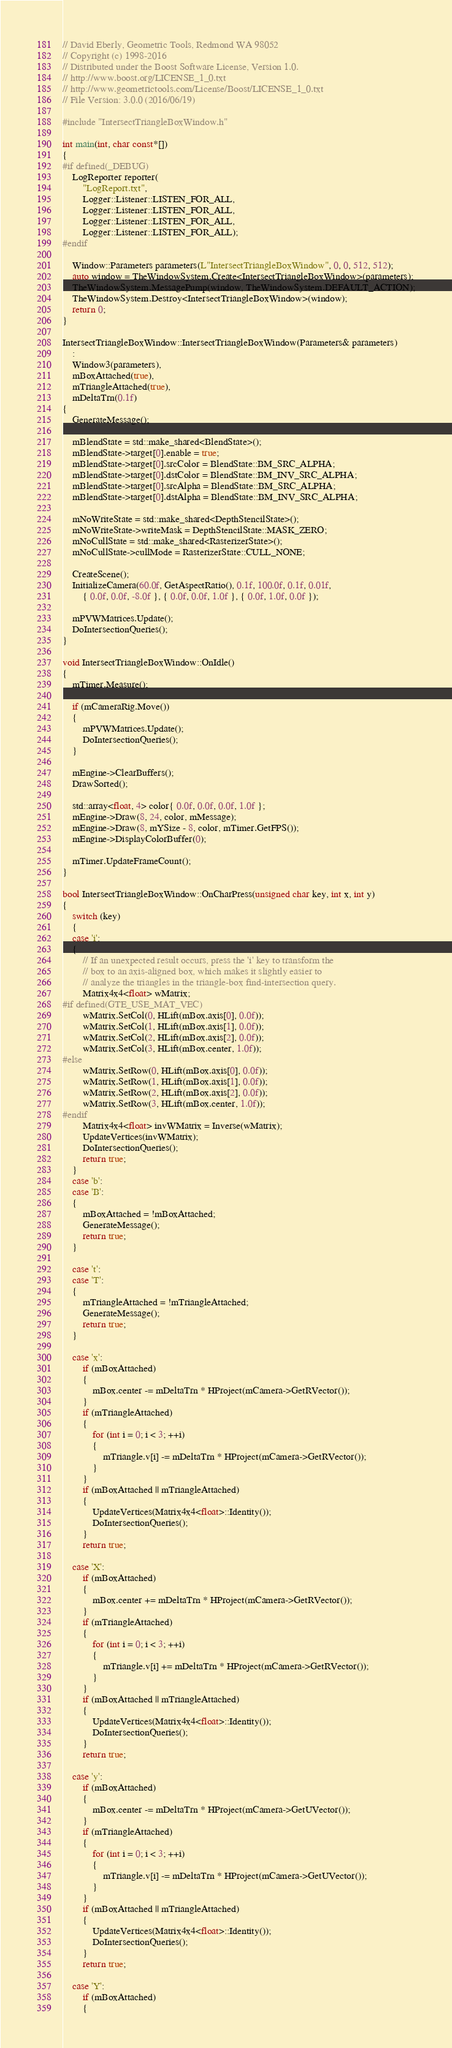<code> <loc_0><loc_0><loc_500><loc_500><_C++_>// David Eberly, Geometric Tools, Redmond WA 98052
// Copyright (c) 1998-2016
// Distributed under the Boost Software License, Version 1.0.
// http://www.boost.org/LICENSE_1_0.txt
// http://www.geometrictools.com/License/Boost/LICENSE_1_0.txt
// File Version: 3.0.0 (2016/06/19)

#include "IntersectTriangleBoxWindow.h"

int main(int, char const*[])
{
#if defined(_DEBUG)
    LogReporter reporter(
        "LogReport.txt",
        Logger::Listener::LISTEN_FOR_ALL,
        Logger::Listener::LISTEN_FOR_ALL,
        Logger::Listener::LISTEN_FOR_ALL,
        Logger::Listener::LISTEN_FOR_ALL);
#endif

    Window::Parameters parameters(L"IntersectTriangleBoxWindow", 0, 0, 512, 512);
    auto window = TheWindowSystem.Create<IntersectTriangleBoxWindow>(parameters);
    TheWindowSystem.MessagePump(window, TheWindowSystem.DEFAULT_ACTION);
    TheWindowSystem.Destroy<IntersectTriangleBoxWindow>(window);
    return 0;
}

IntersectTriangleBoxWindow::IntersectTriangleBoxWindow(Parameters& parameters)
    :
    Window3(parameters),
    mBoxAttached(true),
    mTriangleAttached(true),
    mDeltaTrn(0.1f)
{
    GenerateMessage();

    mBlendState = std::make_shared<BlendState>();
    mBlendState->target[0].enable = true;
    mBlendState->target[0].srcColor = BlendState::BM_SRC_ALPHA;
    mBlendState->target[0].dstColor = BlendState::BM_INV_SRC_ALPHA;
    mBlendState->target[0].srcAlpha = BlendState::BM_SRC_ALPHA;
    mBlendState->target[0].dstAlpha = BlendState::BM_INV_SRC_ALPHA;

    mNoWriteState = std::make_shared<DepthStencilState>();
    mNoWriteState->writeMask = DepthStencilState::MASK_ZERO;
    mNoCullState = std::make_shared<RasterizerState>();
    mNoCullState->cullMode = RasterizerState::CULL_NONE;

    CreateScene();
    InitializeCamera(60.0f, GetAspectRatio(), 0.1f, 100.0f, 0.1f, 0.01f,
        { 0.0f, 0.0f, -8.0f }, { 0.0f, 0.0f, 1.0f }, { 0.0f, 1.0f, 0.0f });

    mPVWMatrices.Update();
    DoIntersectionQueries();
}

void IntersectTriangleBoxWindow::OnIdle()
{
    mTimer.Measure();

    if (mCameraRig.Move())
    {
        mPVWMatrices.Update();
        DoIntersectionQueries();
    }

    mEngine->ClearBuffers();
    DrawSorted();

    std::array<float, 4> color{ 0.0f, 0.0f, 0.0f, 1.0f };
    mEngine->Draw(8, 24, color, mMessage);
    mEngine->Draw(8, mYSize - 8, color, mTimer.GetFPS());
    mEngine->DisplayColorBuffer(0);

    mTimer.UpdateFrameCount();
}

bool IntersectTriangleBoxWindow::OnCharPress(unsigned char key, int x, int y)
{
    switch (key)
    {
    case 'i':
    {
        // If an unexpected result occurs, press the 'i' key to transform the
        // box to an axis-aligned box, which makes it slightly easier to
        // analyze the triangles in the triangle-box find-intersection query.
        Matrix4x4<float> wMatrix;
#if defined(GTE_USE_MAT_VEC)
        wMatrix.SetCol(0, HLift(mBox.axis[0], 0.0f));
        wMatrix.SetCol(1, HLift(mBox.axis[1], 0.0f));
        wMatrix.SetCol(2, HLift(mBox.axis[2], 0.0f));
        wMatrix.SetCol(3, HLift(mBox.center, 1.0f));
#else
        wMatrix.SetRow(0, HLift(mBox.axis[0], 0.0f));
        wMatrix.SetRow(1, HLift(mBox.axis[1], 0.0f));
        wMatrix.SetRow(2, HLift(mBox.axis[2], 0.0f));
        wMatrix.SetRow(3, HLift(mBox.center, 1.0f));
#endif
        Matrix4x4<float> invWMatrix = Inverse(wMatrix);
        UpdateVertices(invWMatrix);
        DoIntersectionQueries();
        return true;
    }
    case 'b':
    case 'B':
    {
        mBoxAttached = !mBoxAttached;
        GenerateMessage();
        return true;
    }

    case 't':
    case 'T':
    {
        mTriangleAttached = !mTriangleAttached;
        GenerateMessage();
        return true;
    }

    case 'x':
        if (mBoxAttached)
        {
            mBox.center -= mDeltaTrn * HProject(mCamera->GetRVector());
        }
        if (mTriangleAttached)
        {
            for (int i = 0; i < 3; ++i)
            {
                mTriangle.v[i] -= mDeltaTrn * HProject(mCamera->GetRVector());
            }
        }
        if (mBoxAttached || mTriangleAttached)
        {
            UpdateVertices(Matrix4x4<float>::Identity());
            DoIntersectionQueries();
        }
        return true;

    case 'X':
        if (mBoxAttached)
        {
            mBox.center += mDeltaTrn * HProject(mCamera->GetRVector());
        }
        if (mTriangleAttached)
        {
            for (int i = 0; i < 3; ++i)
            {
                mTriangle.v[i] += mDeltaTrn * HProject(mCamera->GetRVector());
            }
        }
        if (mBoxAttached || mTriangleAttached)
        {
            UpdateVertices(Matrix4x4<float>::Identity());
            DoIntersectionQueries();
        }
        return true;

    case 'y':
        if (mBoxAttached)
        {
            mBox.center -= mDeltaTrn * HProject(mCamera->GetUVector());
        }
        if (mTriangleAttached)
        {
            for (int i = 0; i < 3; ++i)
            {
                mTriangle.v[i] -= mDeltaTrn * HProject(mCamera->GetUVector());
            }
        }
        if (mBoxAttached || mTriangleAttached)
        {
            UpdateVertices(Matrix4x4<float>::Identity());
            DoIntersectionQueries();
        }
        return true;

    case 'Y':
        if (mBoxAttached)
        {</code> 